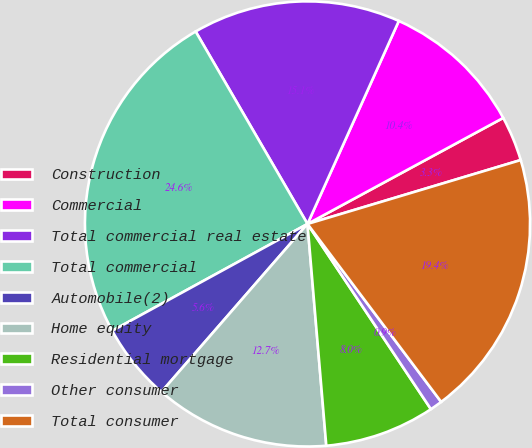<chart> <loc_0><loc_0><loc_500><loc_500><pie_chart><fcel>Construction<fcel>Commercial<fcel>Total commercial real estate<fcel>Total commercial<fcel>Automobile(2)<fcel>Home equity<fcel>Residential mortgage<fcel>Other consumer<fcel>Total consumer<nl><fcel>3.27%<fcel>10.37%<fcel>15.11%<fcel>24.59%<fcel>5.64%<fcel>12.74%<fcel>8.01%<fcel>0.9%<fcel>19.38%<nl></chart> 